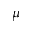<formula> <loc_0><loc_0><loc_500><loc_500>\mu</formula> 